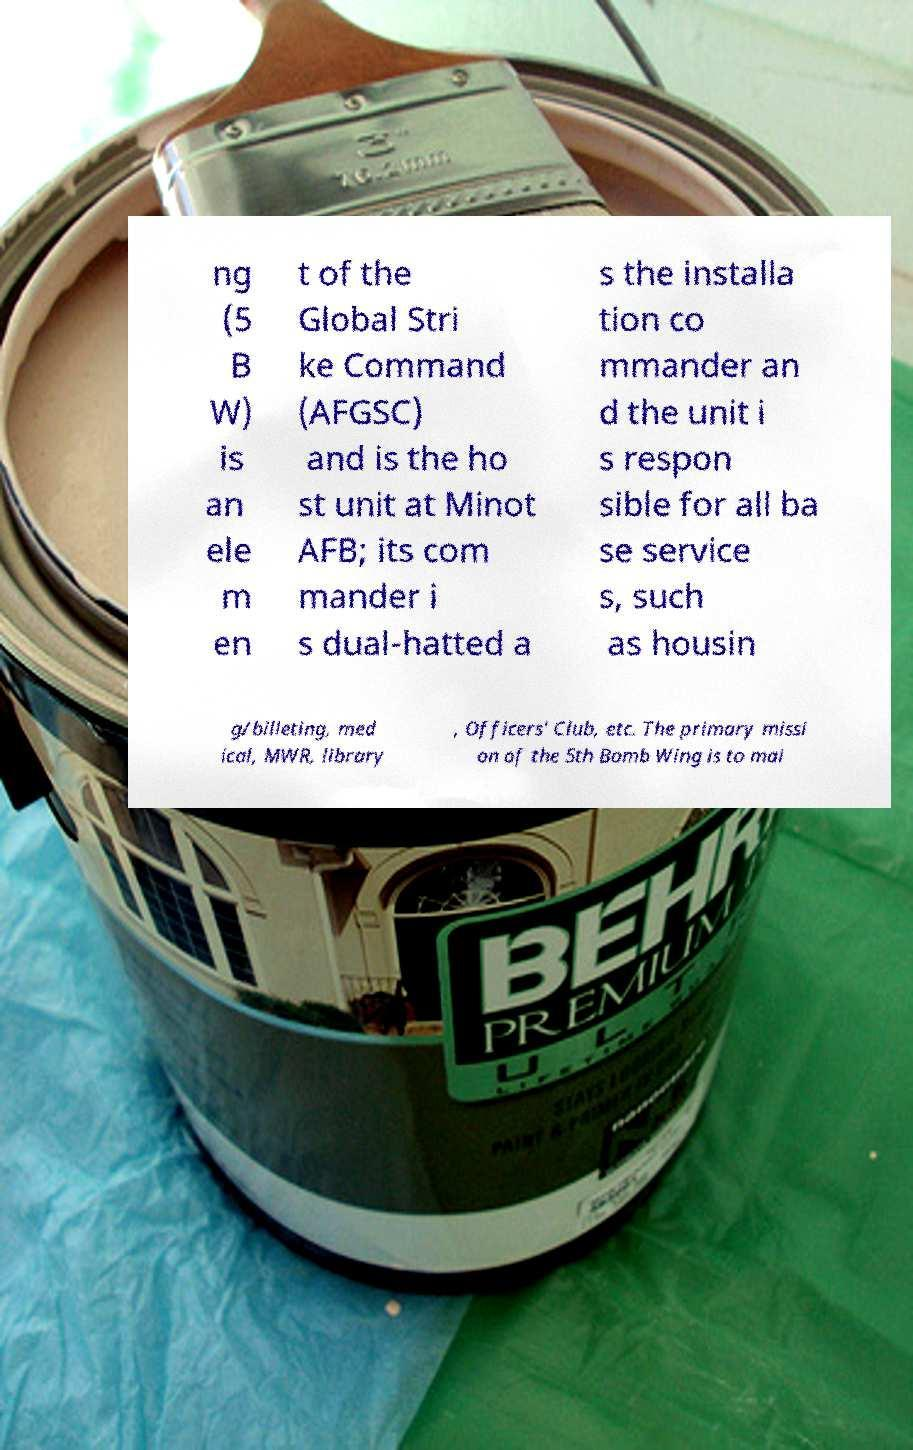Please identify and transcribe the text found in this image. ng (5 B W) is an ele m en t of the Global Stri ke Command (AFGSC) and is the ho st unit at Minot AFB; its com mander i s dual-hatted a s the installa tion co mmander an d the unit i s respon sible for all ba se service s, such as housin g/billeting, med ical, MWR, library , Officers' Club, etc. The primary missi on of the 5th Bomb Wing is to mai 